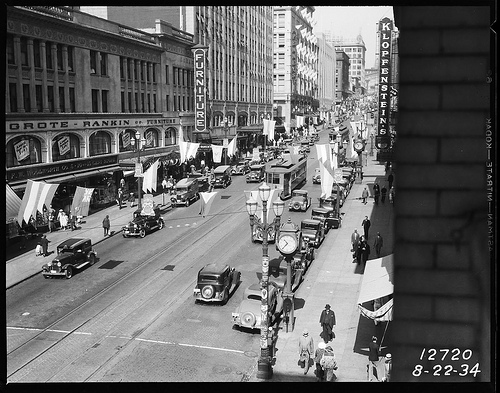<image>Was this picture taken on Wall Street? I am not sure if this picture was taken on Wall Street. The opinions are divided. Was this picture taken on Wall Street? I don't know if this picture was taken on Wall Street. It is not clear from the given information. 